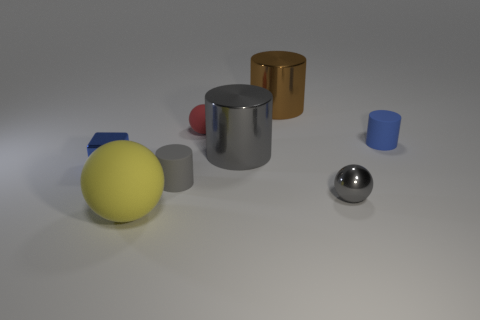There is a small rubber thing to the right of the rubber sphere behind the shiny thing in front of the small blue block; what is its shape?
Give a very brief answer. Cylinder. What material is the large thing that is the same shape as the tiny gray metallic thing?
Your answer should be very brief. Rubber. What number of tiny matte cylinders are there?
Ensure brevity in your answer.  2. What shape is the tiny blue thing that is left of the big yellow ball?
Keep it short and to the point. Cube. There is a tiny metal thing behind the tiny cylinder that is in front of the small blue object left of the small red thing; what is its color?
Keep it short and to the point. Blue. The blue thing that is the same material as the brown thing is what shape?
Offer a terse response. Cube. Are there fewer tiny balls than small gray matte things?
Your answer should be compact. No. Do the small blue block and the yellow ball have the same material?
Provide a short and direct response. No. How many other things are there of the same color as the small shiny cube?
Make the answer very short. 1. Is the number of big matte balls greater than the number of tiny balls?
Offer a terse response. No. 